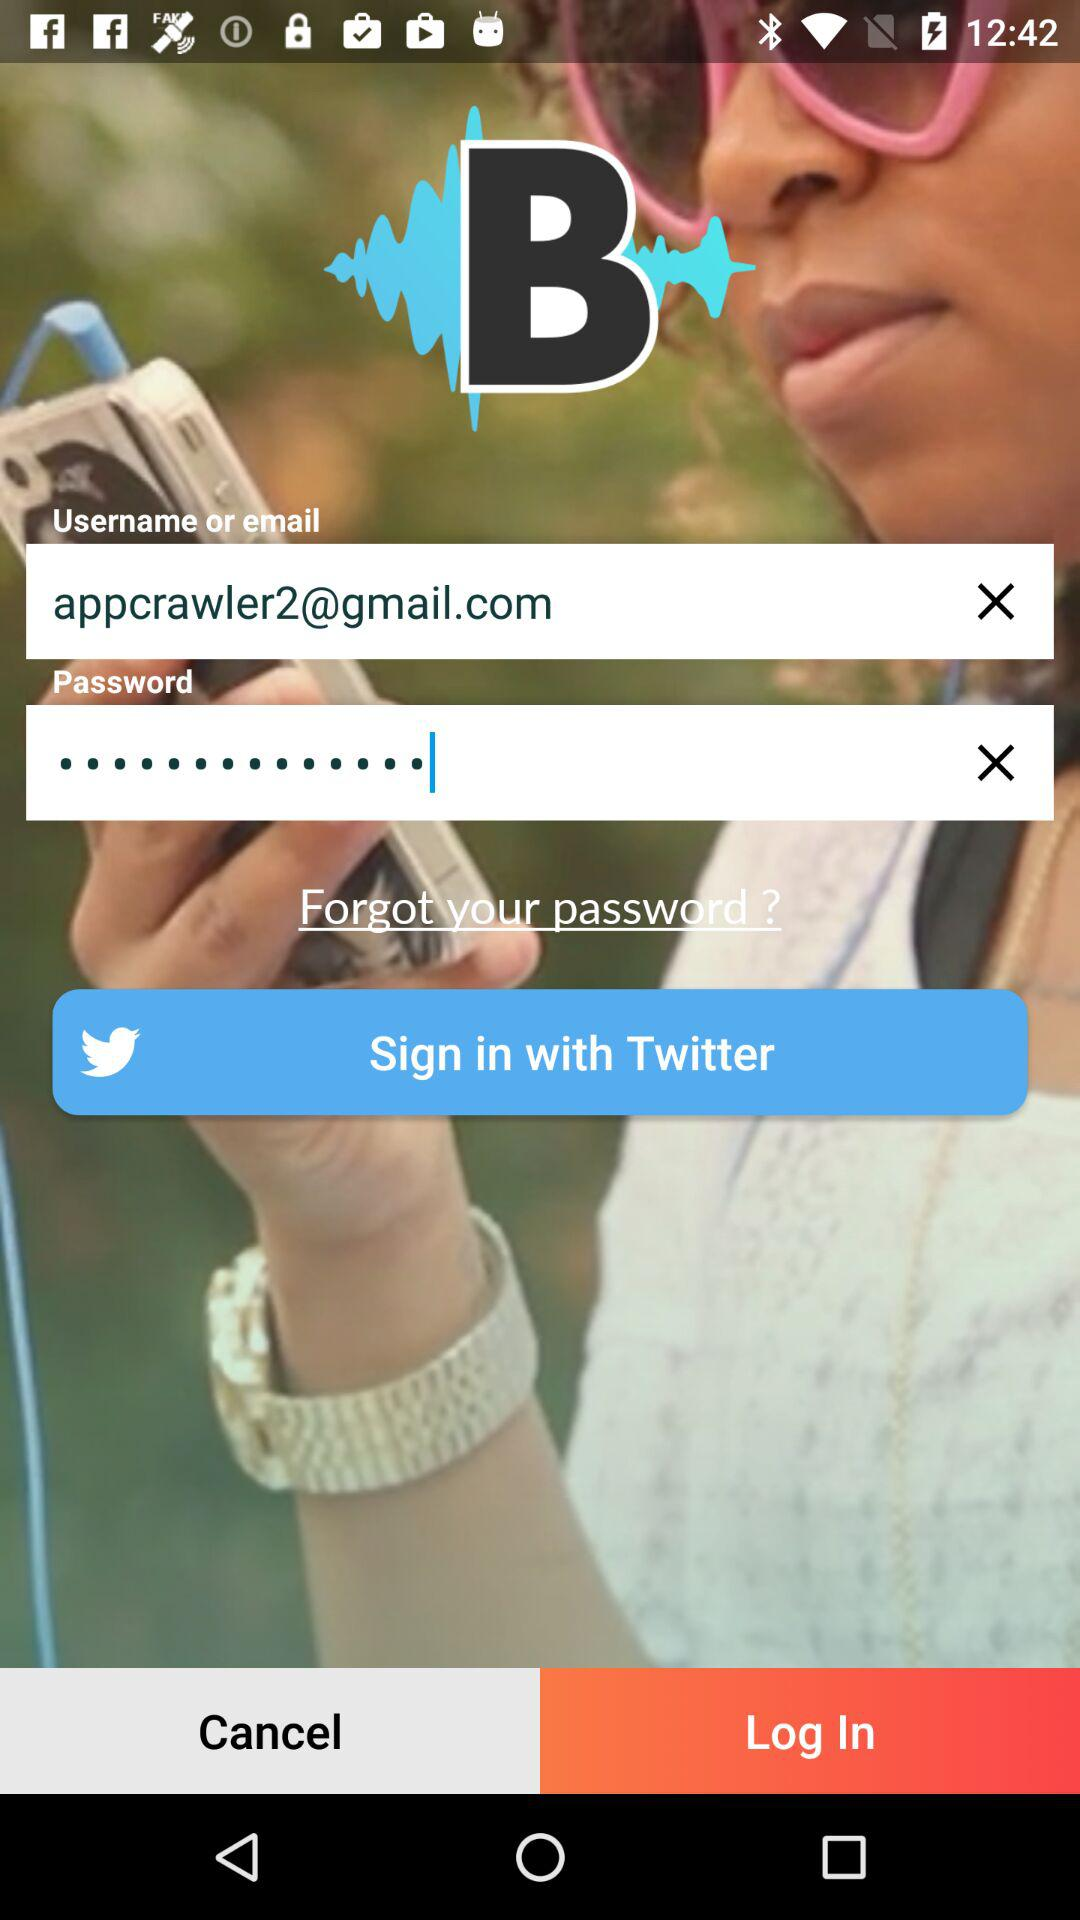How many text input fields are there on the screen?
Answer the question using a single word or phrase. 2 